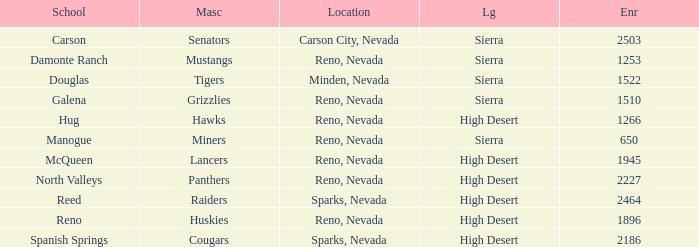Which school has the Raiders as their mascot? Reed. 